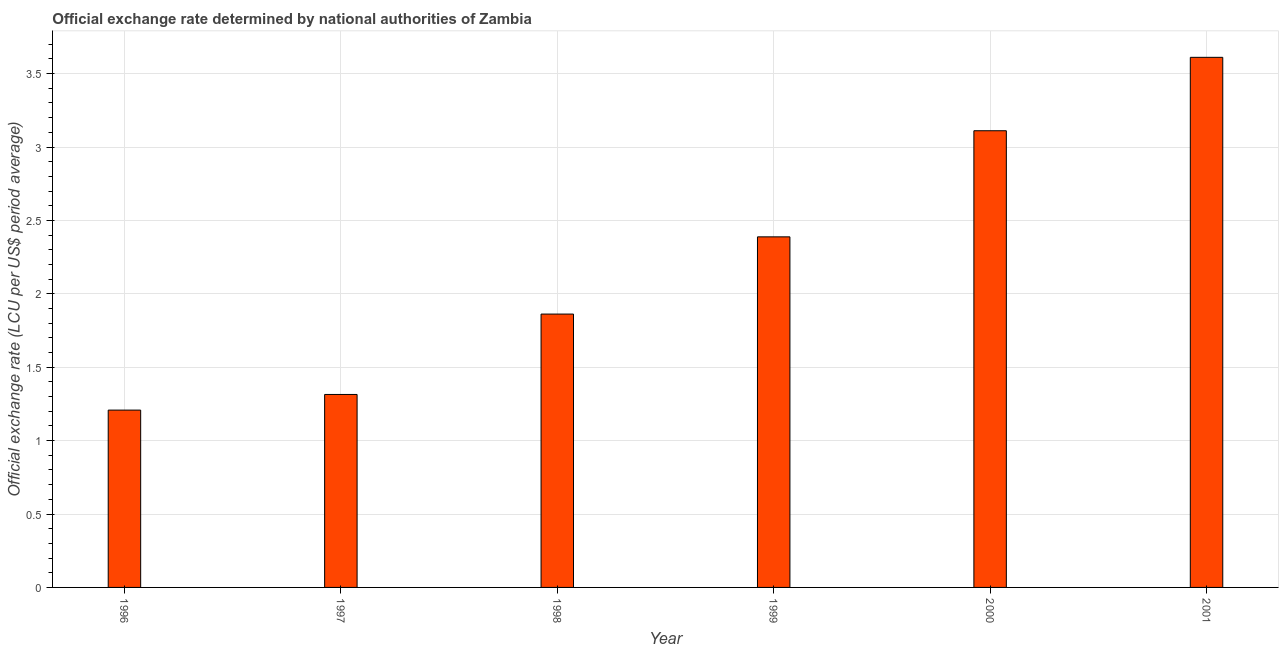Does the graph contain any zero values?
Ensure brevity in your answer.  No. Does the graph contain grids?
Give a very brief answer. Yes. What is the title of the graph?
Provide a short and direct response. Official exchange rate determined by national authorities of Zambia. What is the label or title of the X-axis?
Provide a short and direct response. Year. What is the label or title of the Y-axis?
Give a very brief answer. Official exchange rate (LCU per US$ period average). What is the official exchange rate in 2000?
Give a very brief answer. 3.11. Across all years, what is the maximum official exchange rate?
Give a very brief answer. 3.61. Across all years, what is the minimum official exchange rate?
Ensure brevity in your answer.  1.21. What is the sum of the official exchange rate?
Provide a short and direct response. 13.49. What is the difference between the official exchange rate in 1996 and 1999?
Offer a very short reply. -1.18. What is the average official exchange rate per year?
Give a very brief answer. 2.25. What is the median official exchange rate?
Your answer should be compact. 2.13. In how many years, is the official exchange rate greater than 1.2 ?
Make the answer very short. 6. What is the ratio of the official exchange rate in 2000 to that in 2001?
Your response must be concise. 0.86. Is the difference between the official exchange rate in 1999 and 2000 greater than the difference between any two years?
Keep it short and to the point. No. In how many years, is the official exchange rate greater than the average official exchange rate taken over all years?
Offer a very short reply. 3. What is the Official exchange rate (LCU per US$ period average) in 1996?
Offer a very short reply. 1.21. What is the Official exchange rate (LCU per US$ period average) in 1997?
Make the answer very short. 1.31. What is the Official exchange rate (LCU per US$ period average) in 1998?
Your response must be concise. 1.86. What is the Official exchange rate (LCU per US$ period average) of 1999?
Your answer should be very brief. 2.39. What is the Official exchange rate (LCU per US$ period average) in 2000?
Your answer should be compact. 3.11. What is the Official exchange rate (LCU per US$ period average) of 2001?
Provide a succinct answer. 3.61. What is the difference between the Official exchange rate (LCU per US$ period average) in 1996 and 1997?
Give a very brief answer. -0.11. What is the difference between the Official exchange rate (LCU per US$ period average) in 1996 and 1998?
Keep it short and to the point. -0.65. What is the difference between the Official exchange rate (LCU per US$ period average) in 1996 and 1999?
Provide a succinct answer. -1.18. What is the difference between the Official exchange rate (LCU per US$ period average) in 1996 and 2000?
Your answer should be compact. -1.9. What is the difference between the Official exchange rate (LCU per US$ period average) in 1996 and 2001?
Offer a terse response. -2.4. What is the difference between the Official exchange rate (LCU per US$ period average) in 1997 and 1998?
Your answer should be compact. -0.55. What is the difference between the Official exchange rate (LCU per US$ period average) in 1997 and 1999?
Offer a very short reply. -1.07. What is the difference between the Official exchange rate (LCU per US$ period average) in 1997 and 2000?
Offer a very short reply. -1.8. What is the difference between the Official exchange rate (LCU per US$ period average) in 1997 and 2001?
Give a very brief answer. -2.3. What is the difference between the Official exchange rate (LCU per US$ period average) in 1998 and 1999?
Your answer should be compact. -0.53. What is the difference between the Official exchange rate (LCU per US$ period average) in 1998 and 2000?
Offer a very short reply. -1.25. What is the difference between the Official exchange rate (LCU per US$ period average) in 1998 and 2001?
Offer a terse response. -1.75. What is the difference between the Official exchange rate (LCU per US$ period average) in 1999 and 2000?
Give a very brief answer. -0.72. What is the difference between the Official exchange rate (LCU per US$ period average) in 1999 and 2001?
Provide a succinct answer. -1.22. What is the difference between the Official exchange rate (LCU per US$ period average) in 2000 and 2001?
Provide a succinct answer. -0.5. What is the ratio of the Official exchange rate (LCU per US$ period average) in 1996 to that in 1997?
Offer a terse response. 0.92. What is the ratio of the Official exchange rate (LCU per US$ period average) in 1996 to that in 1998?
Ensure brevity in your answer.  0.65. What is the ratio of the Official exchange rate (LCU per US$ period average) in 1996 to that in 1999?
Ensure brevity in your answer.  0.51. What is the ratio of the Official exchange rate (LCU per US$ period average) in 1996 to that in 2000?
Your answer should be very brief. 0.39. What is the ratio of the Official exchange rate (LCU per US$ period average) in 1996 to that in 2001?
Your answer should be very brief. 0.34. What is the ratio of the Official exchange rate (LCU per US$ period average) in 1997 to that in 1998?
Ensure brevity in your answer.  0.71. What is the ratio of the Official exchange rate (LCU per US$ period average) in 1997 to that in 1999?
Give a very brief answer. 0.55. What is the ratio of the Official exchange rate (LCU per US$ period average) in 1997 to that in 2000?
Give a very brief answer. 0.42. What is the ratio of the Official exchange rate (LCU per US$ period average) in 1997 to that in 2001?
Your response must be concise. 0.36. What is the ratio of the Official exchange rate (LCU per US$ period average) in 1998 to that in 1999?
Your answer should be compact. 0.78. What is the ratio of the Official exchange rate (LCU per US$ period average) in 1998 to that in 2000?
Ensure brevity in your answer.  0.6. What is the ratio of the Official exchange rate (LCU per US$ period average) in 1998 to that in 2001?
Your response must be concise. 0.52. What is the ratio of the Official exchange rate (LCU per US$ period average) in 1999 to that in 2000?
Provide a short and direct response. 0.77. What is the ratio of the Official exchange rate (LCU per US$ period average) in 1999 to that in 2001?
Ensure brevity in your answer.  0.66. What is the ratio of the Official exchange rate (LCU per US$ period average) in 2000 to that in 2001?
Your response must be concise. 0.86. 